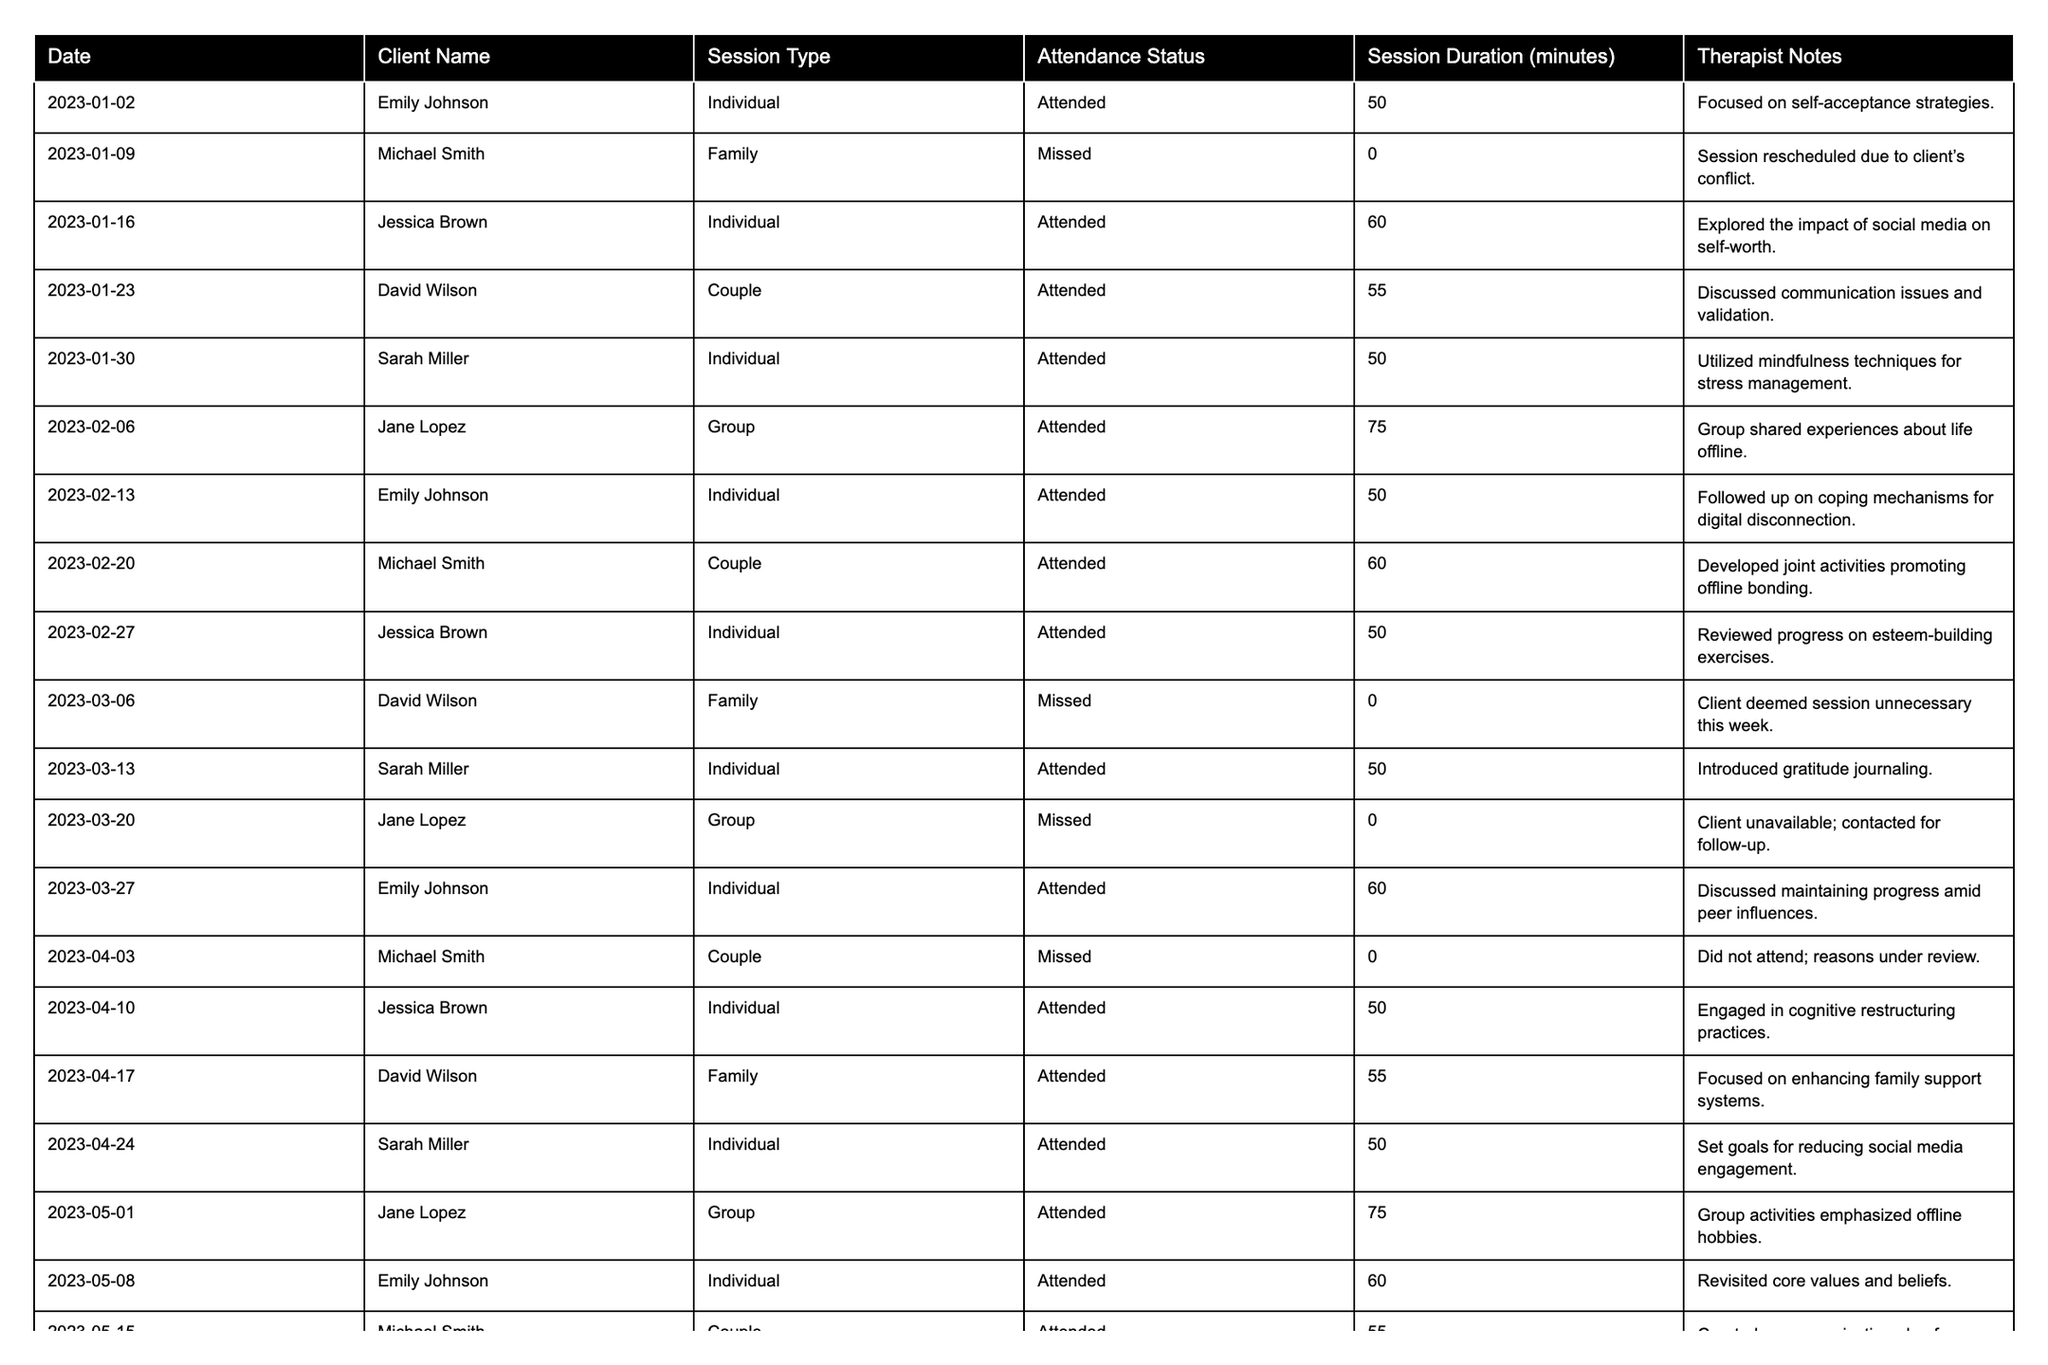What is the attendance status of Jessica Brown on January 16th? The table shows that on January 16th, Jessica Brown attended an individual session.
Answer: Attended How many sessions did Emily Johnson miss in total? Reviewing the table, Emily Johnson attended all her scheduled sessions, so the count of missed sessions is 0.
Answer: 0 What was the average session duration for David Wilson's family sessions? David Wilson had three family sessions: 0 (missed), 55 (attended), and 0 (missed). The average is calculated as (55) / 1 = 55 minutes since we only consider the attended session.
Answer: 55 Did Jane Lopez attend more sessions than Michael Smith? Jane Lopez attended 4 sessions while Michael Smith attended 4 as well. Therefore, they attended an equal number of sessions.
Answer: No What is the total attendance rate for all clients over the six months? There were 24 scheduled sessions, out of which 20 were attended. The attendance rate is calculated as (20 attended / 24 total) * 100 = 83.33%.
Answer: 83.33% How many individual sessions did Sarah Miller attend in total? Reviewing the table, Sarah Miller attended five individual sessions over the six months.
Answer: 5 What percentage of missed sessions were for family therapy? Out of the four missed sessions (2 family and 2 group), the percentage of missed family therapy sessions is (2 / 4) * 100 = 50%.
Answer: 50% Which client attended the most sessions, and how many? By counting the attendance for each client, Emily Johnson attended 7 sessions, which is the highest compared to others.
Answer: Emily Johnson, 7 sessions What were the therapist's notes for the first session of Michael Smith? The first session of Michael Smith on January 9th was missed, hence there are no therapist notes.
Answer: No notes available What session had the longest duration, and who was the client? The longest session was on June 12th for Jane Lopez, with a duration of 80 minutes.
Answer: June 12th, Jane Lopez, 80 minutes 